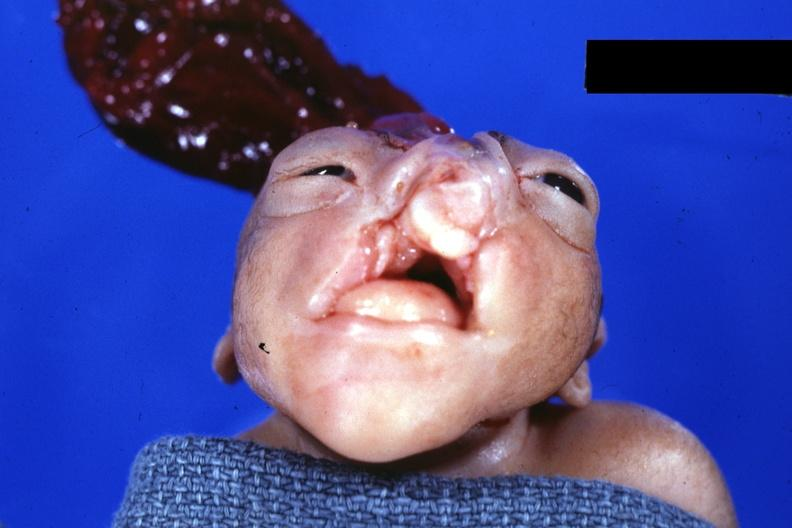s anencephaly and bilateral cleft palate present?
Answer the question using a single word or phrase. Yes 